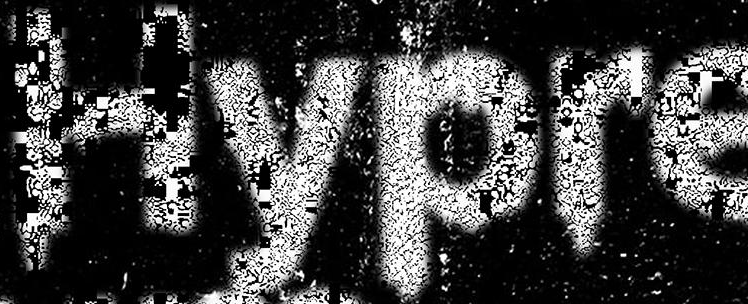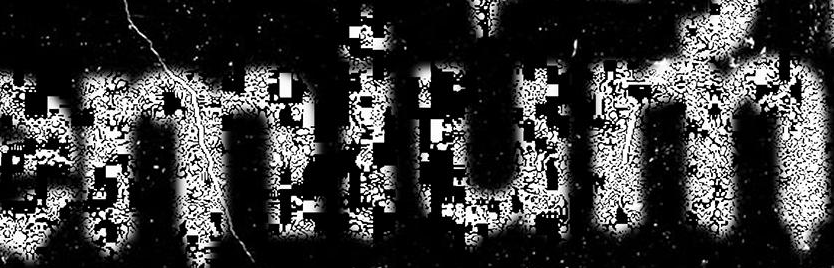What words are shown in these images in order, separated by a semicolon? Hypre; emium 